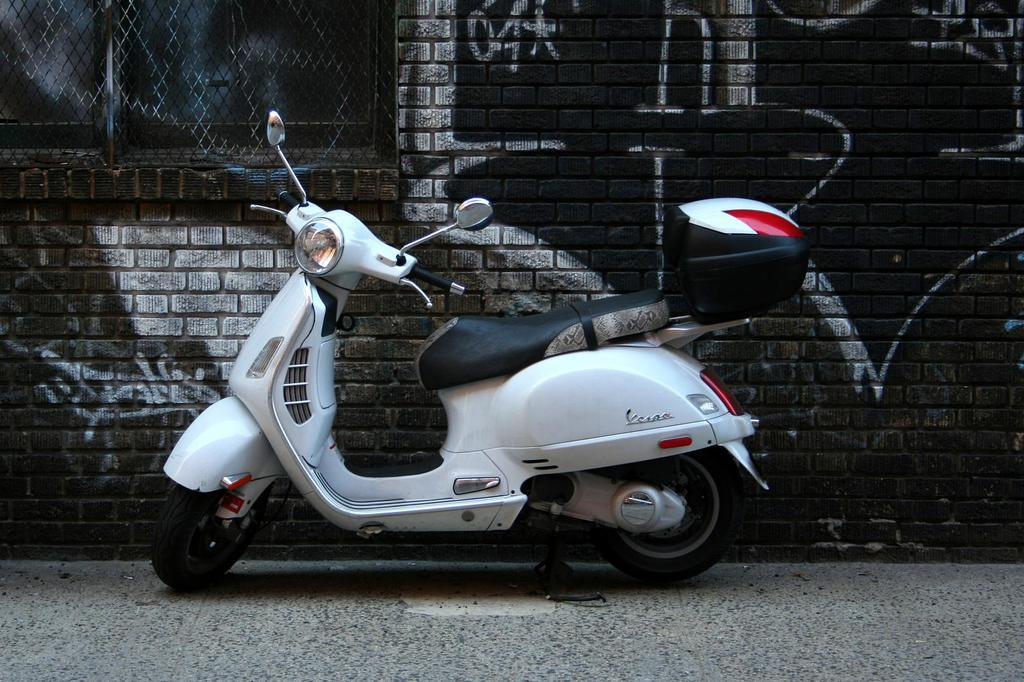What type of vehicle is in the image? There is a white scooter in the image. What can be seen in the background of the image? There is a building in the background of the image. Can you describe any specific features of the building? The building has a window on the left side. Are there any dinosaurs visible in the image? No, there are no dinosaurs present in the image. What type of produce is being sold near the scooter? There is no produce visible in the image; it only features a white scooter and a building in the background. 